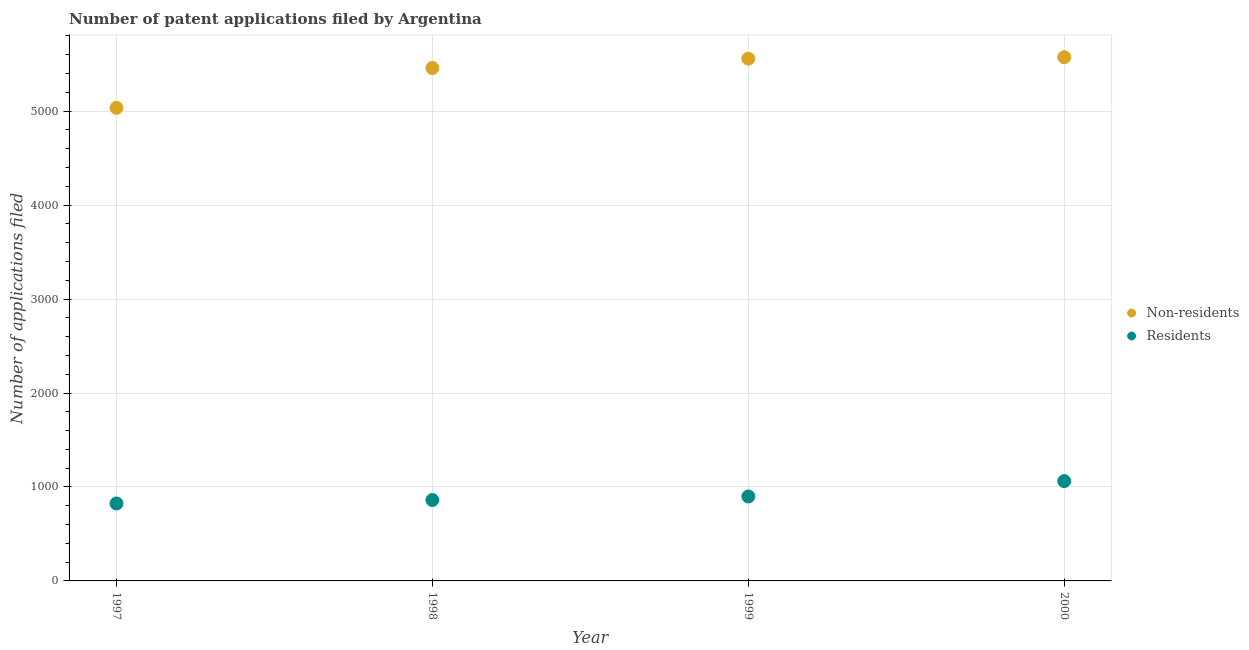How many different coloured dotlines are there?
Offer a very short reply. 2. What is the number of patent applications by residents in 2000?
Offer a very short reply. 1062. Across all years, what is the maximum number of patent applications by non residents?
Make the answer very short. 5574. Across all years, what is the minimum number of patent applications by non residents?
Provide a succinct answer. 5035. In which year was the number of patent applications by residents maximum?
Your answer should be compact. 2000. In which year was the number of patent applications by residents minimum?
Give a very brief answer. 1997. What is the total number of patent applications by non residents in the graph?
Ensure brevity in your answer.  2.16e+04. What is the difference between the number of patent applications by non residents in 1998 and that in 2000?
Provide a short and direct response. -115. What is the difference between the number of patent applications by residents in 1999 and the number of patent applications by non residents in 1998?
Your answer should be compact. -4560. What is the average number of patent applications by non residents per year?
Ensure brevity in your answer.  5406.5. In the year 1998, what is the difference between the number of patent applications by residents and number of patent applications by non residents?
Offer a terse response. -4598. What is the ratio of the number of patent applications by residents in 1997 to that in 1998?
Provide a short and direct response. 0.96. Is the number of patent applications by residents in 1998 less than that in 2000?
Provide a succinct answer. Yes. What is the difference between the highest and the second highest number of patent applications by residents?
Provide a succinct answer. 163. What is the difference between the highest and the lowest number of patent applications by residents?
Give a very brief answer. 238. Is the sum of the number of patent applications by non residents in 1997 and 1998 greater than the maximum number of patent applications by residents across all years?
Make the answer very short. Yes. Is the number of patent applications by non residents strictly greater than the number of patent applications by residents over the years?
Provide a short and direct response. Yes. Is the number of patent applications by residents strictly less than the number of patent applications by non residents over the years?
Give a very brief answer. Yes. How many dotlines are there?
Your answer should be very brief. 2. How many years are there in the graph?
Your response must be concise. 4. Are the values on the major ticks of Y-axis written in scientific E-notation?
Your answer should be compact. No. Does the graph contain grids?
Ensure brevity in your answer.  Yes. Where does the legend appear in the graph?
Offer a very short reply. Center right. What is the title of the graph?
Your answer should be very brief. Number of patent applications filed by Argentina. What is the label or title of the Y-axis?
Your answer should be very brief. Number of applications filed. What is the Number of applications filed of Non-residents in 1997?
Provide a succinct answer. 5035. What is the Number of applications filed of Residents in 1997?
Your response must be concise. 824. What is the Number of applications filed of Non-residents in 1998?
Offer a very short reply. 5459. What is the Number of applications filed of Residents in 1998?
Your answer should be compact. 861. What is the Number of applications filed in Non-residents in 1999?
Keep it short and to the point. 5558. What is the Number of applications filed in Residents in 1999?
Your response must be concise. 899. What is the Number of applications filed of Non-residents in 2000?
Provide a succinct answer. 5574. What is the Number of applications filed of Residents in 2000?
Offer a terse response. 1062. Across all years, what is the maximum Number of applications filed in Non-residents?
Offer a terse response. 5574. Across all years, what is the maximum Number of applications filed in Residents?
Provide a short and direct response. 1062. Across all years, what is the minimum Number of applications filed in Non-residents?
Provide a short and direct response. 5035. Across all years, what is the minimum Number of applications filed in Residents?
Your answer should be compact. 824. What is the total Number of applications filed in Non-residents in the graph?
Provide a succinct answer. 2.16e+04. What is the total Number of applications filed in Residents in the graph?
Your answer should be very brief. 3646. What is the difference between the Number of applications filed in Non-residents in 1997 and that in 1998?
Ensure brevity in your answer.  -424. What is the difference between the Number of applications filed in Residents in 1997 and that in 1998?
Your response must be concise. -37. What is the difference between the Number of applications filed in Non-residents in 1997 and that in 1999?
Provide a short and direct response. -523. What is the difference between the Number of applications filed of Residents in 1997 and that in 1999?
Give a very brief answer. -75. What is the difference between the Number of applications filed in Non-residents in 1997 and that in 2000?
Your answer should be compact. -539. What is the difference between the Number of applications filed of Residents in 1997 and that in 2000?
Ensure brevity in your answer.  -238. What is the difference between the Number of applications filed in Non-residents in 1998 and that in 1999?
Provide a succinct answer. -99. What is the difference between the Number of applications filed of Residents in 1998 and that in 1999?
Your response must be concise. -38. What is the difference between the Number of applications filed in Non-residents in 1998 and that in 2000?
Give a very brief answer. -115. What is the difference between the Number of applications filed of Residents in 1998 and that in 2000?
Keep it short and to the point. -201. What is the difference between the Number of applications filed of Residents in 1999 and that in 2000?
Ensure brevity in your answer.  -163. What is the difference between the Number of applications filed in Non-residents in 1997 and the Number of applications filed in Residents in 1998?
Offer a terse response. 4174. What is the difference between the Number of applications filed in Non-residents in 1997 and the Number of applications filed in Residents in 1999?
Keep it short and to the point. 4136. What is the difference between the Number of applications filed in Non-residents in 1997 and the Number of applications filed in Residents in 2000?
Give a very brief answer. 3973. What is the difference between the Number of applications filed in Non-residents in 1998 and the Number of applications filed in Residents in 1999?
Your answer should be very brief. 4560. What is the difference between the Number of applications filed in Non-residents in 1998 and the Number of applications filed in Residents in 2000?
Provide a succinct answer. 4397. What is the difference between the Number of applications filed in Non-residents in 1999 and the Number of applications filed in Residents in 2000?
Provide a short and direct response. 4496. What is the average Number of applications filed of Non-residents per year?
Make the answer very short. 5406.5. What is the average Number of applications filed of Residents per year?
Offer a terse response. 911.5. In the year 1997, what is the difference between the Number of applications filed of Non-residents and Number of applications filed of Residents?
Keep it short and to the point. 4211. In the year 1998, what is the difference between the Number of applications filed of Non-residents and Number of applications filed of Residents?
Offer a terse response. 4598. In the year 1999, what is the difference between the Number of applications filed in Non-residents and Number of applications filed in Residents?
Provide a short and direct response. 4659. In the year 2000, what is the difference between the Number of applications filed in Non-residents and Number of applications filed in Residents?
Offer a very short reply. 4512. What is the ratio of the Number of applications filed in Non-residents in 1997 to that in 1998?
Provide a short and direct response. 0.92. What is the ratio of the Number of applications filed in Non-residents in 1997 to that in 1999?
Offer a terse response. 0.91. What is the ratio of the Number of applications filed in Residents in 1997 to that in 1999?
Offer a very short reply. 0.92. What is the ratio of the Number of applications filed in Non-residents in 1997 to that in 2000?
Ensure brevity in your answer.  0.9. What is the ratio of the Number of applications filed in Residents in 1997 to that in 2000?
Your answer should be compact. 0.78. What is the ratio of the Number of applications filed in Non-residents in 1998 to that in 1999?
Offer a terse response. 0.98. What is the ratio of the Number of applications filed of Residents in 1998 to that in 1999?
Make the answer very short. 0.96. What is the ratio of the Number of applications filed in Non-residents in 1998 to that in 2000?
Your answer should be compact. 0.98. What is the ratio of the Number of applications filed of Residents in 1998 to that in 2000?
Provide a succinct answer. 0.81. What is the ratio of the Number of applications filed of Residents in 1999 to that in 2000?
Offer a terse response. 0.85. What is the difference between the highest and the second highest Number of applications filed of Residents?
Offer a terse response. 163. What is the difference between the highest and the lowest Number of applications filed in Non-residents?
Offer a very short reply. 539. What is the difference between the highest and the lowest Number of applications filed of Residents?
Keep it short and to the point. 238. 